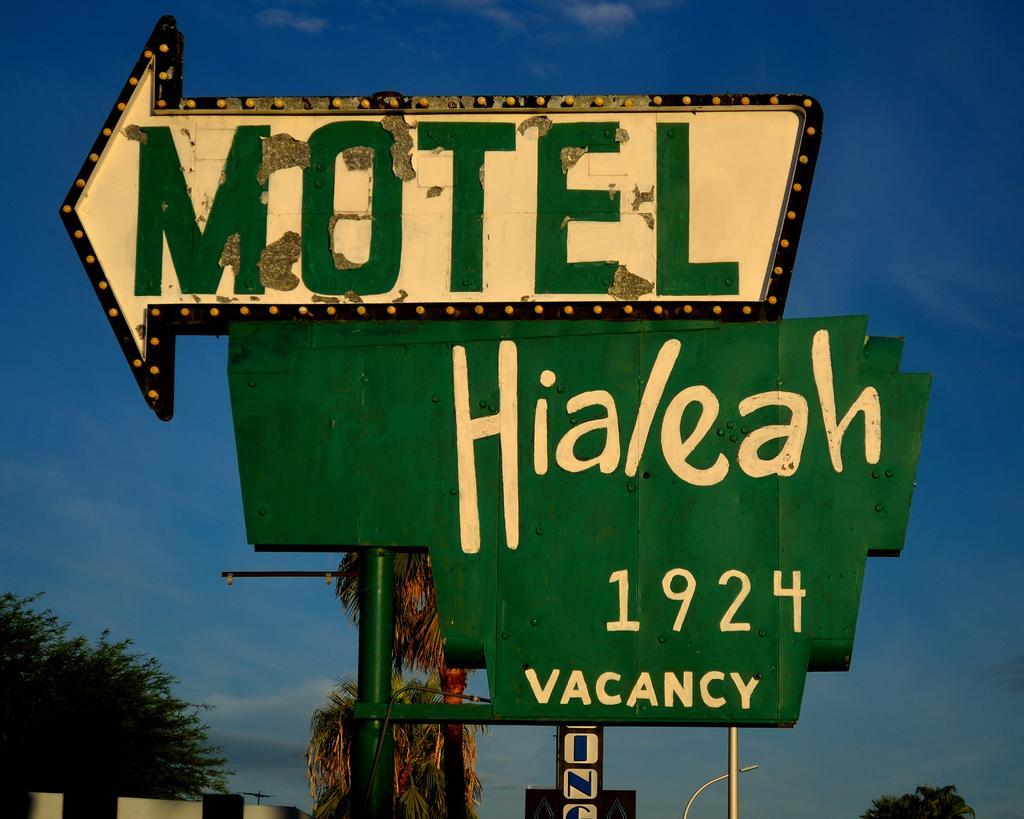Could you give a brief overview of what you see in this image? In this image I can see few boards are attached to the pole. I can see few trees, poles and the sky is in blue color. 